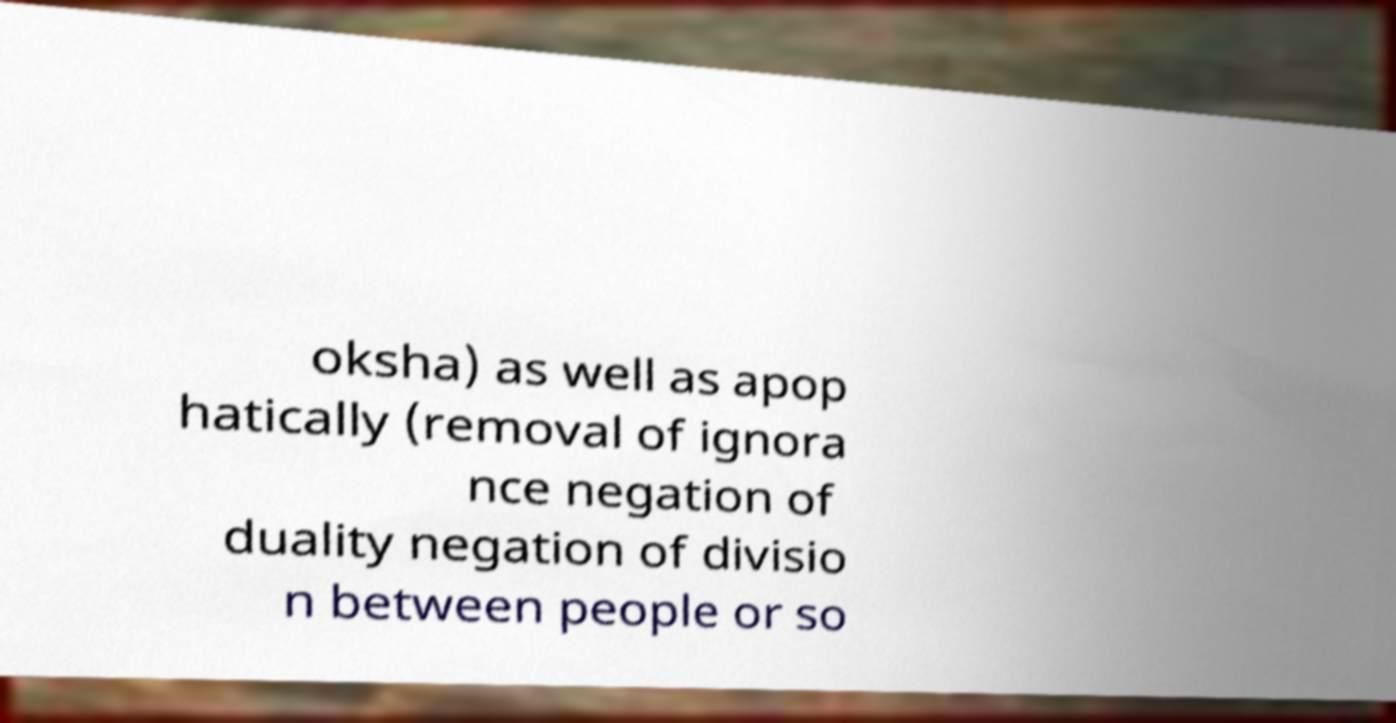Please read and relay the text visible in this image. What does it say? oksha) as well as apop hatically (removal of ignora nce negation of duality negation of divisio n between people or so 